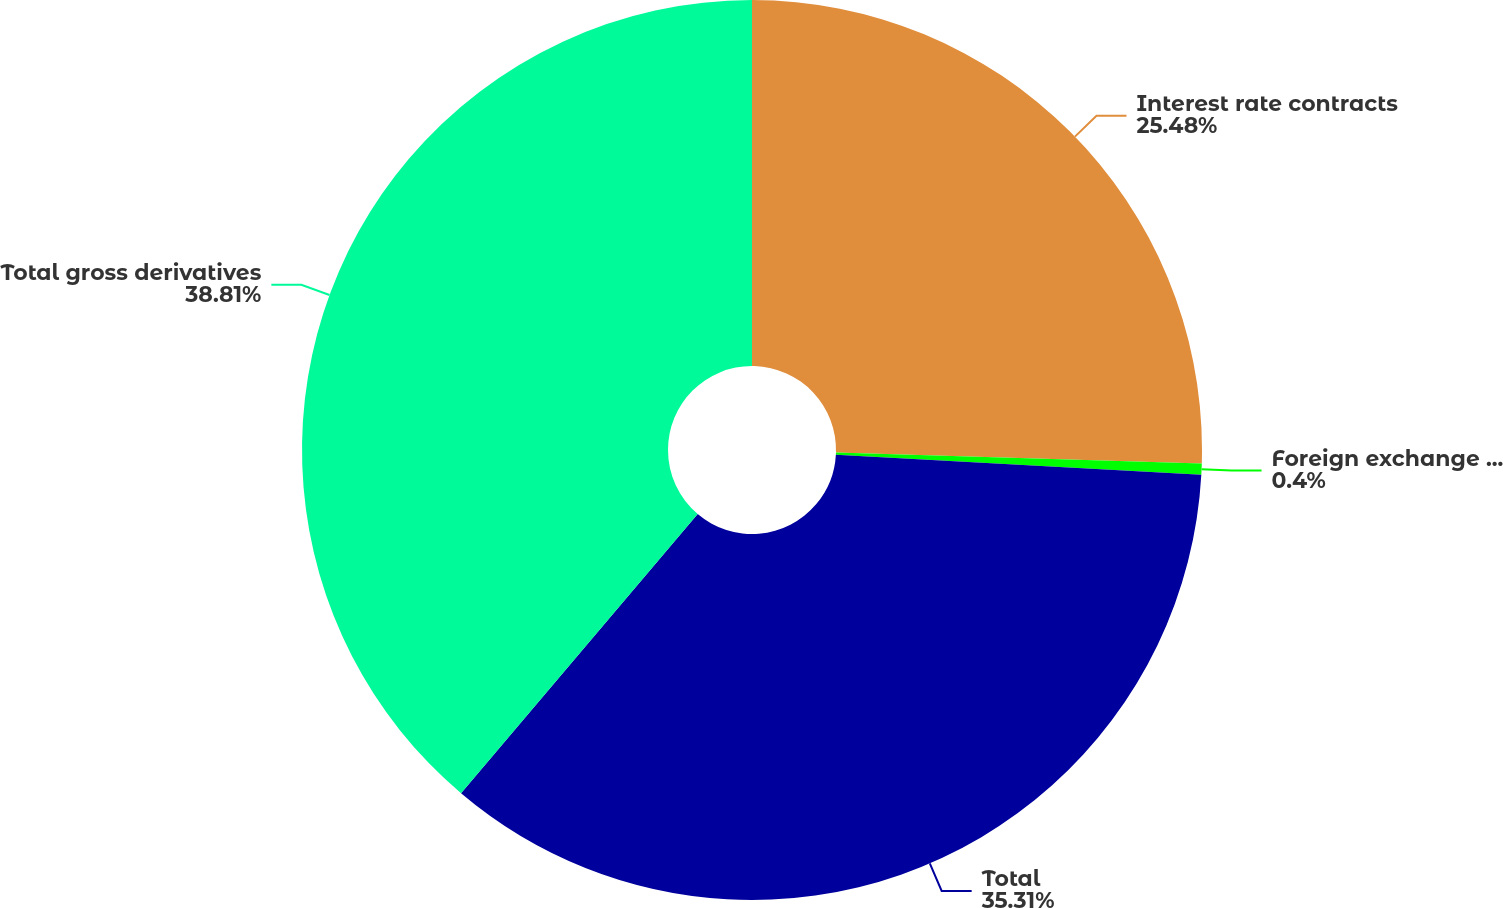<chart> <loc_0><loc_0><loc_500><loc_500><pie_chart><fcel>Interest rate contracts<fcel>Foreign exchange contracts<fcel>Total<fcel>Total gross derivatives<nl><fcel>25.48%<fcel>0.4%<fcel>35.31%<fcel>38.81%<nl></chart> 